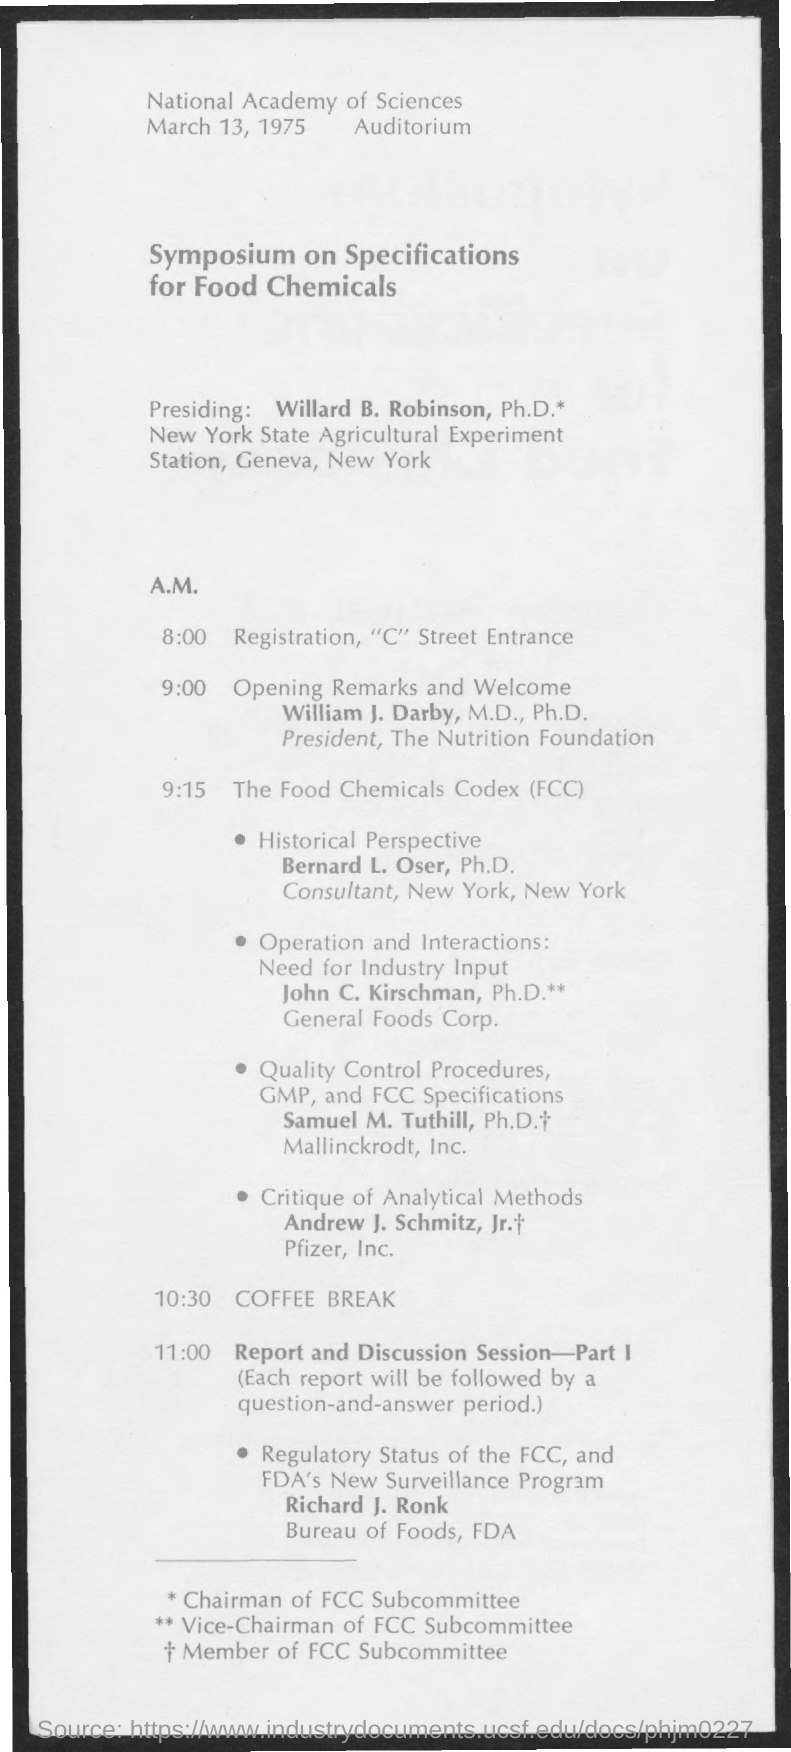Indicate a few pertinent items in this graphic. Registration is slated to take place at 8:00... The symposium will take place on March 13, 1975. The opening remarks and welcome will commence at 9:00. The presiding individual is Dr. Willard B. Robinson, holding a Ph.D. Dr. William J. Darby, M.D., Ph.D., will be delivering the opening remarks and welcoming attendees at the event. 